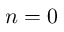Convert formula to latex. <formula><loc_0><loc_0><loc_500><loc_500>n = 0</formula> 